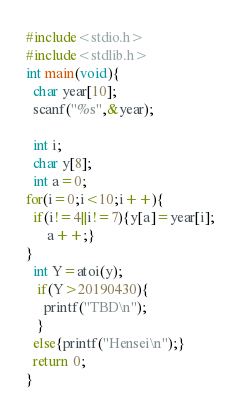Convert code to text. <code><loc_0><loc_0><loc_500><loc_500><_C_>#include<stdio.h>
#include<stdlib.h>
int main(void){
  char year[10];
  scanf("%s",&year);
  
  int i;
  char y[8];
  int a=0;
for(i=0;i<10;i++){
  if(i!=4||i!=7){y[a]=year[i];
      a++;}
}
  int Y=atoi(y);
   if(Y>20190430){
     printf("TBD\n");
   }
  else{printf("Hensei\n");}
  return 0;
}</code> 